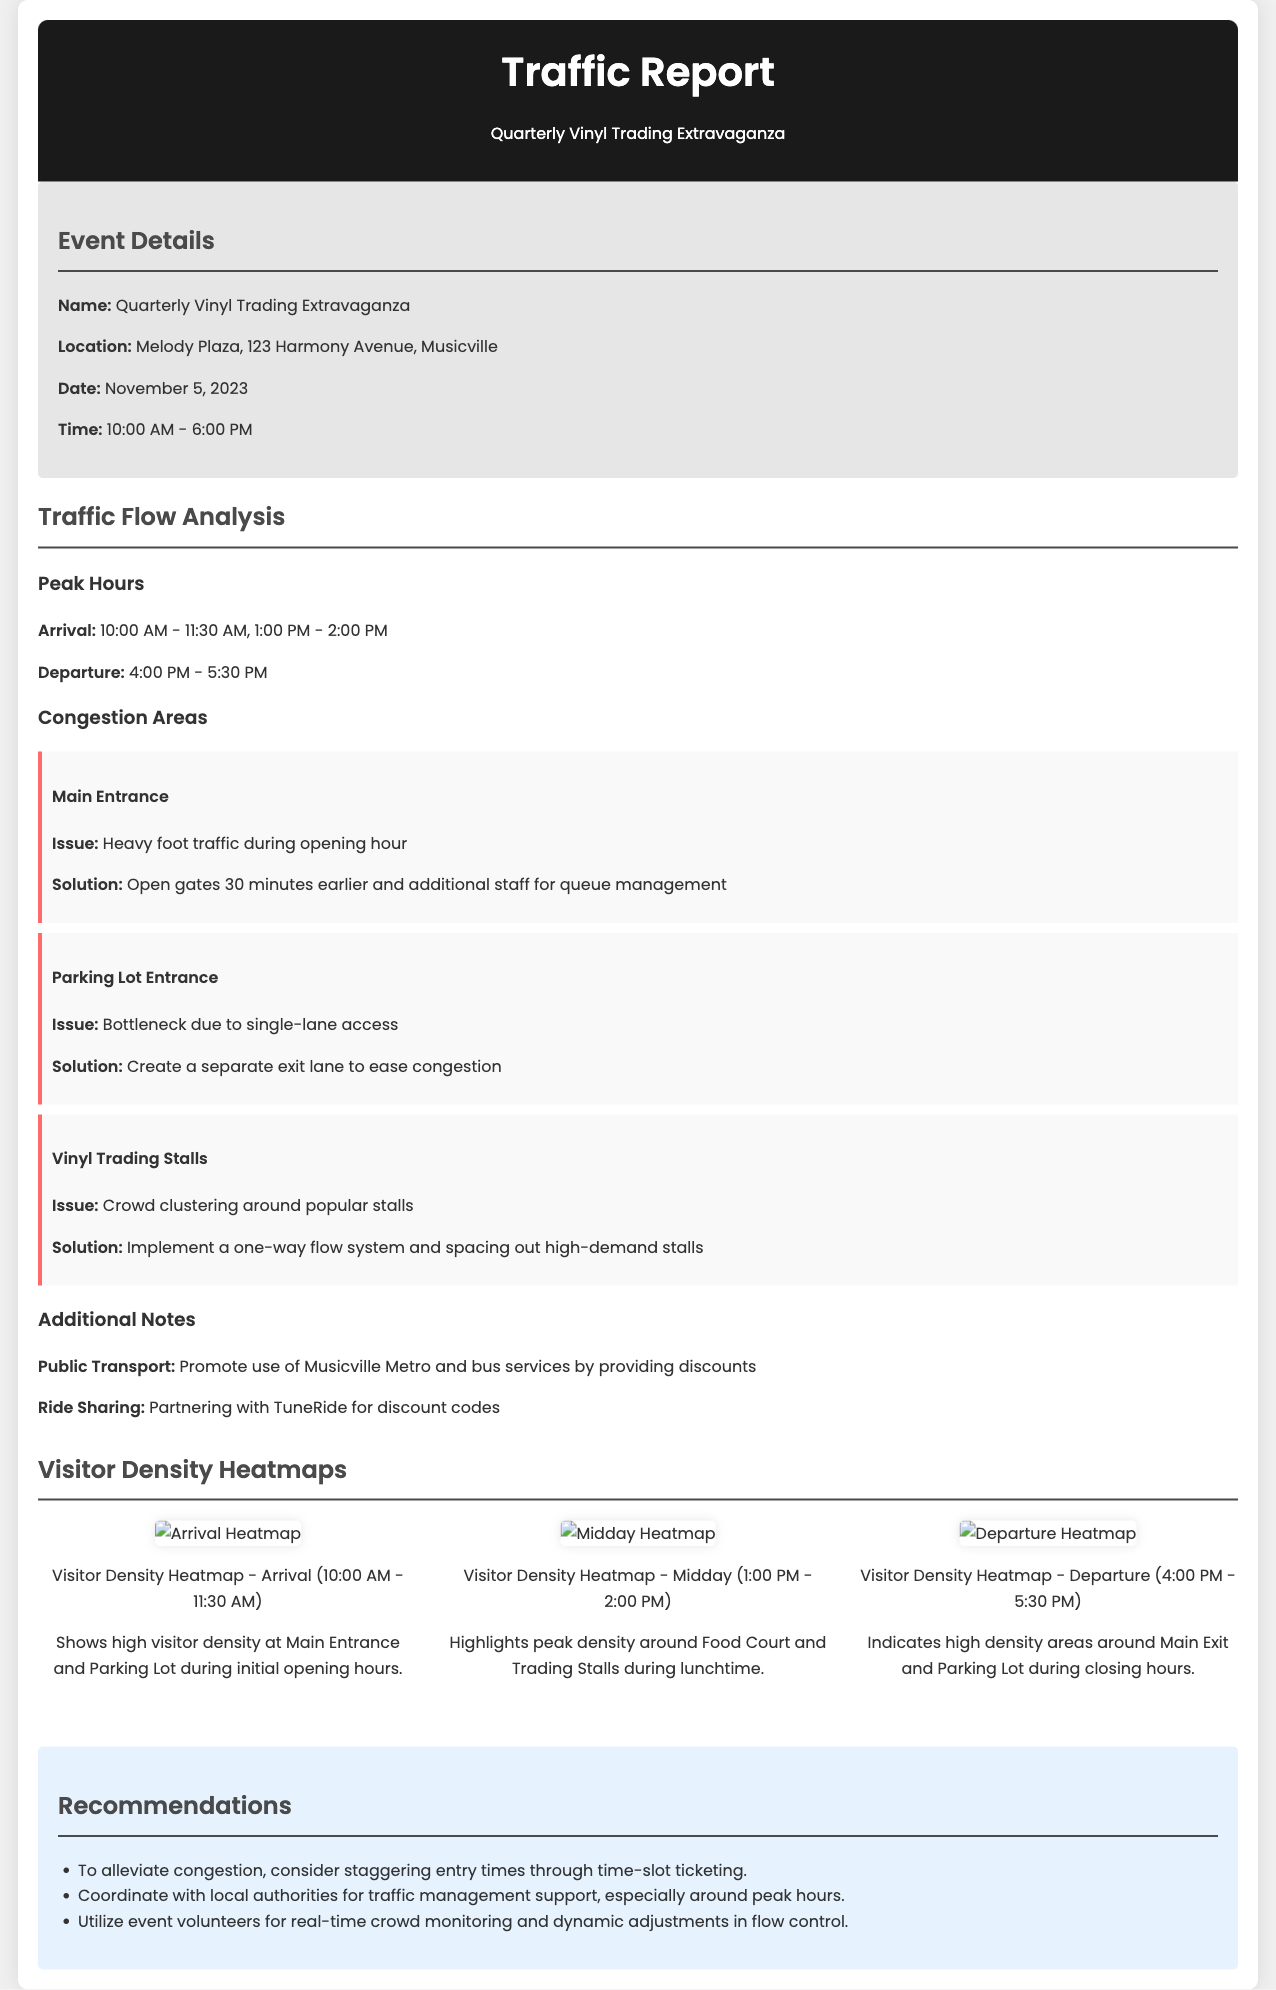what is the date of the event? The date of the event is specified in the document as November 5, 2023.
Answer: November 5, 2023 what are the peak arrival hours? The peak arrival hours are stated in the document as the times when most visitors arrive. They are 10:00 AM - 11:30 AM and 1:00 PM - 2:00 PM.
Answer: 10:00 AM - 11:30 AM, 1:00 PM - 2:00 PM what is one of the congestion areas? The congestion areas highlight the spots where crowding regularly occurs, such as the Main Entrance.
Answer: Main Entrance what solution is proposed for the parking lot entrance congestion? The proposed solution to the parking lot entrance congestion involves making changes to improve flow. It suggests creating a separate exit lane to ease congestion.
Answer: Create a separate exit lane how does the midday heatmap describe visitor density? The midday heatmap visualizes traffic during lunchtime, indicating density near food options.
Answer: Highlights peak density around Food Court and Trading Stalls what time will the event start? The start time of the event is listed in the document, showing when activities begin for visitors.
Answer: 10:00 AM which service is being promoted for public transport? A specific public transport service is mentioned to encourage attendees to use it as part of their journey.
Answer: Musicville Metro how many heatmaps are included in the report? The report contains visual representations of visitor density across different times, categorized by arrival, midday, and departure, summing to three distinct visuals.
Answer: Three 